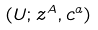<formula> <loc_0><loc_0><loc_500><loc_500>( U ; z ^ { A } , c ^ { a } )</formula> 